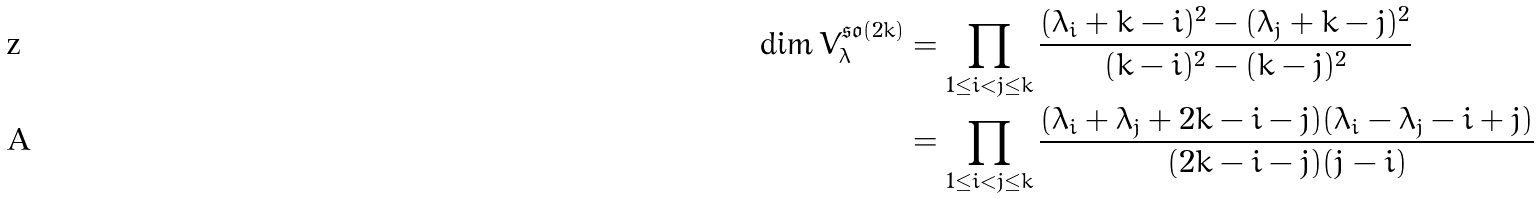<formula> <loc_0><loc_0><loc_500><loc_500>\dim V ^ { \mathfrak { s o } ( 2 k ) } _ { \lambda } & = \prod _ { 1 \leq i < j \leq k } \frac { ( \lambda _ { i } + k - i ) ^ { 2 } - ( \lambda _ { j } + k - j ) ^ { 2 } } { ( k - i ) ^ { 2 } - ( k - j ) ^ { 2 } } \\ & = \prod _ { 1 \leq i < j \leq k } \frac { ( \lambda _ { i } + \lambda _ { j } + 2 k - i - j ) ( \lambda _ { i } - \lambda _ { j } - i + j ) } { ( 2 k - i - j ) ( j - i ) }</formula> 